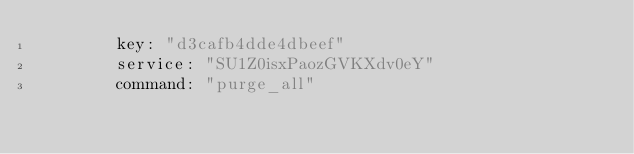<code> <loc_0><loc_0><loc_500><loc_500><_YAML_>        key: "d3cafb4dde4dbeef"
        service: "SU1Z0isxPaozGVKXdv0eY"
        command: "purge_all"
</code> 